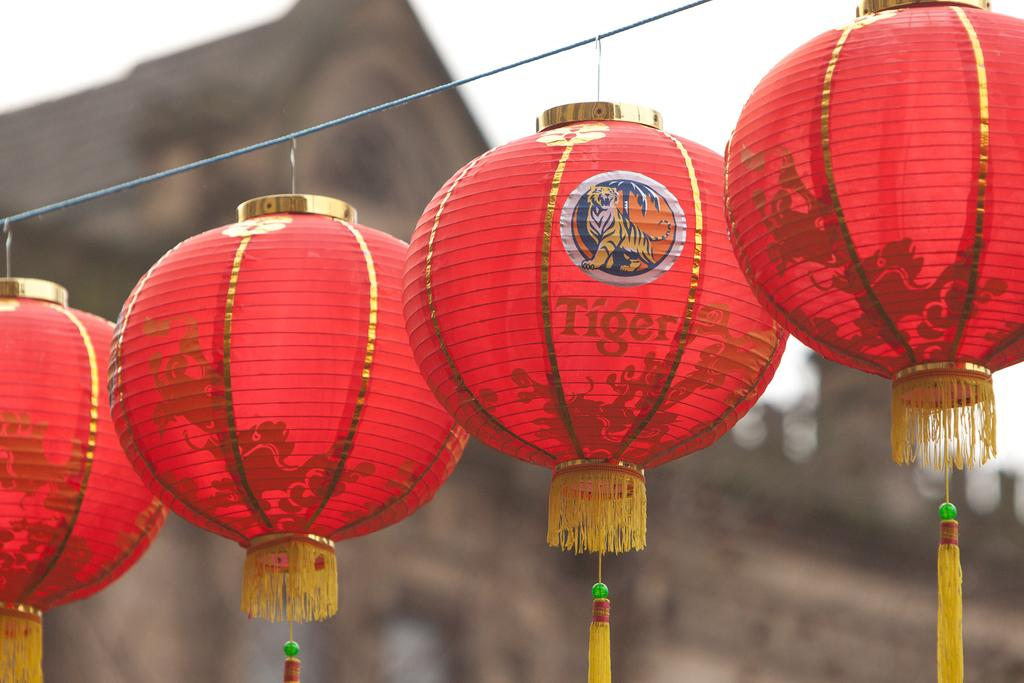What color are the balls in the image? The balls in the image are red. How many balls are there in the image? There are four balls in the image. Is there anything attached to the balls? Yes, a yellow color thread is attached to the balls. What colors are used in the background of the image? The background of the image is in brown and white color. Are there any deer visible in the image? No, there are no deer present in the image. What type of amusement can be seen in the image? There is no amusement present in the image; it features four red balls with a yellow thread attached. 